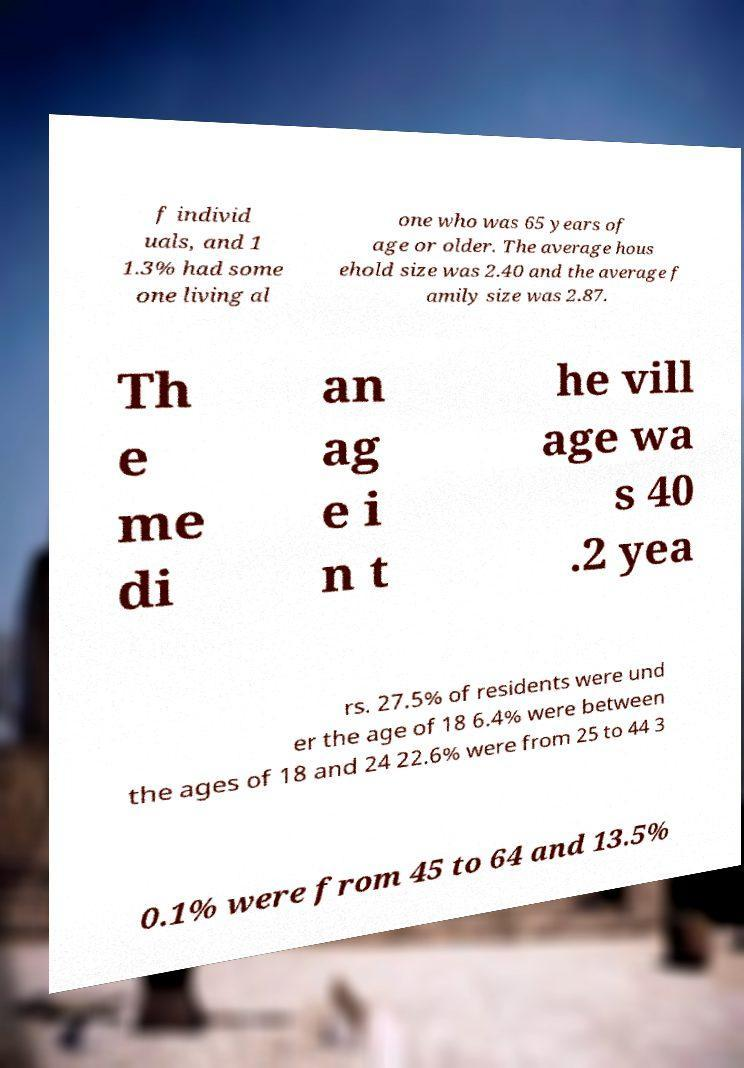There's text embedded in this image that I need extracted. Can you transcribe it verbatim? f individ uals, and 1 1.3% had some one living al one who was 65 years of age or older. The average hous ehold size was 2.40 and the average f amily size was 2.87. Th e me di an ag e i n t he vill age wa s 40 .2 yea rs. 27.5% of residents were und er the age of 18 6.4% were between the ages of 18 and 24 22.6% were from 25 to 44 3 0.1% were from 45 to 64 and 13.5% 